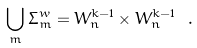Convert formula to latex. <formula><loc_0><loc_0><loc_500><loc_500>\bigcup _ { m } \Sigma _ { m } ^ { w } = W _ { n } ^ { k - 1 } \times W _ { n } ^ { k - 1 } \ .</formula> 